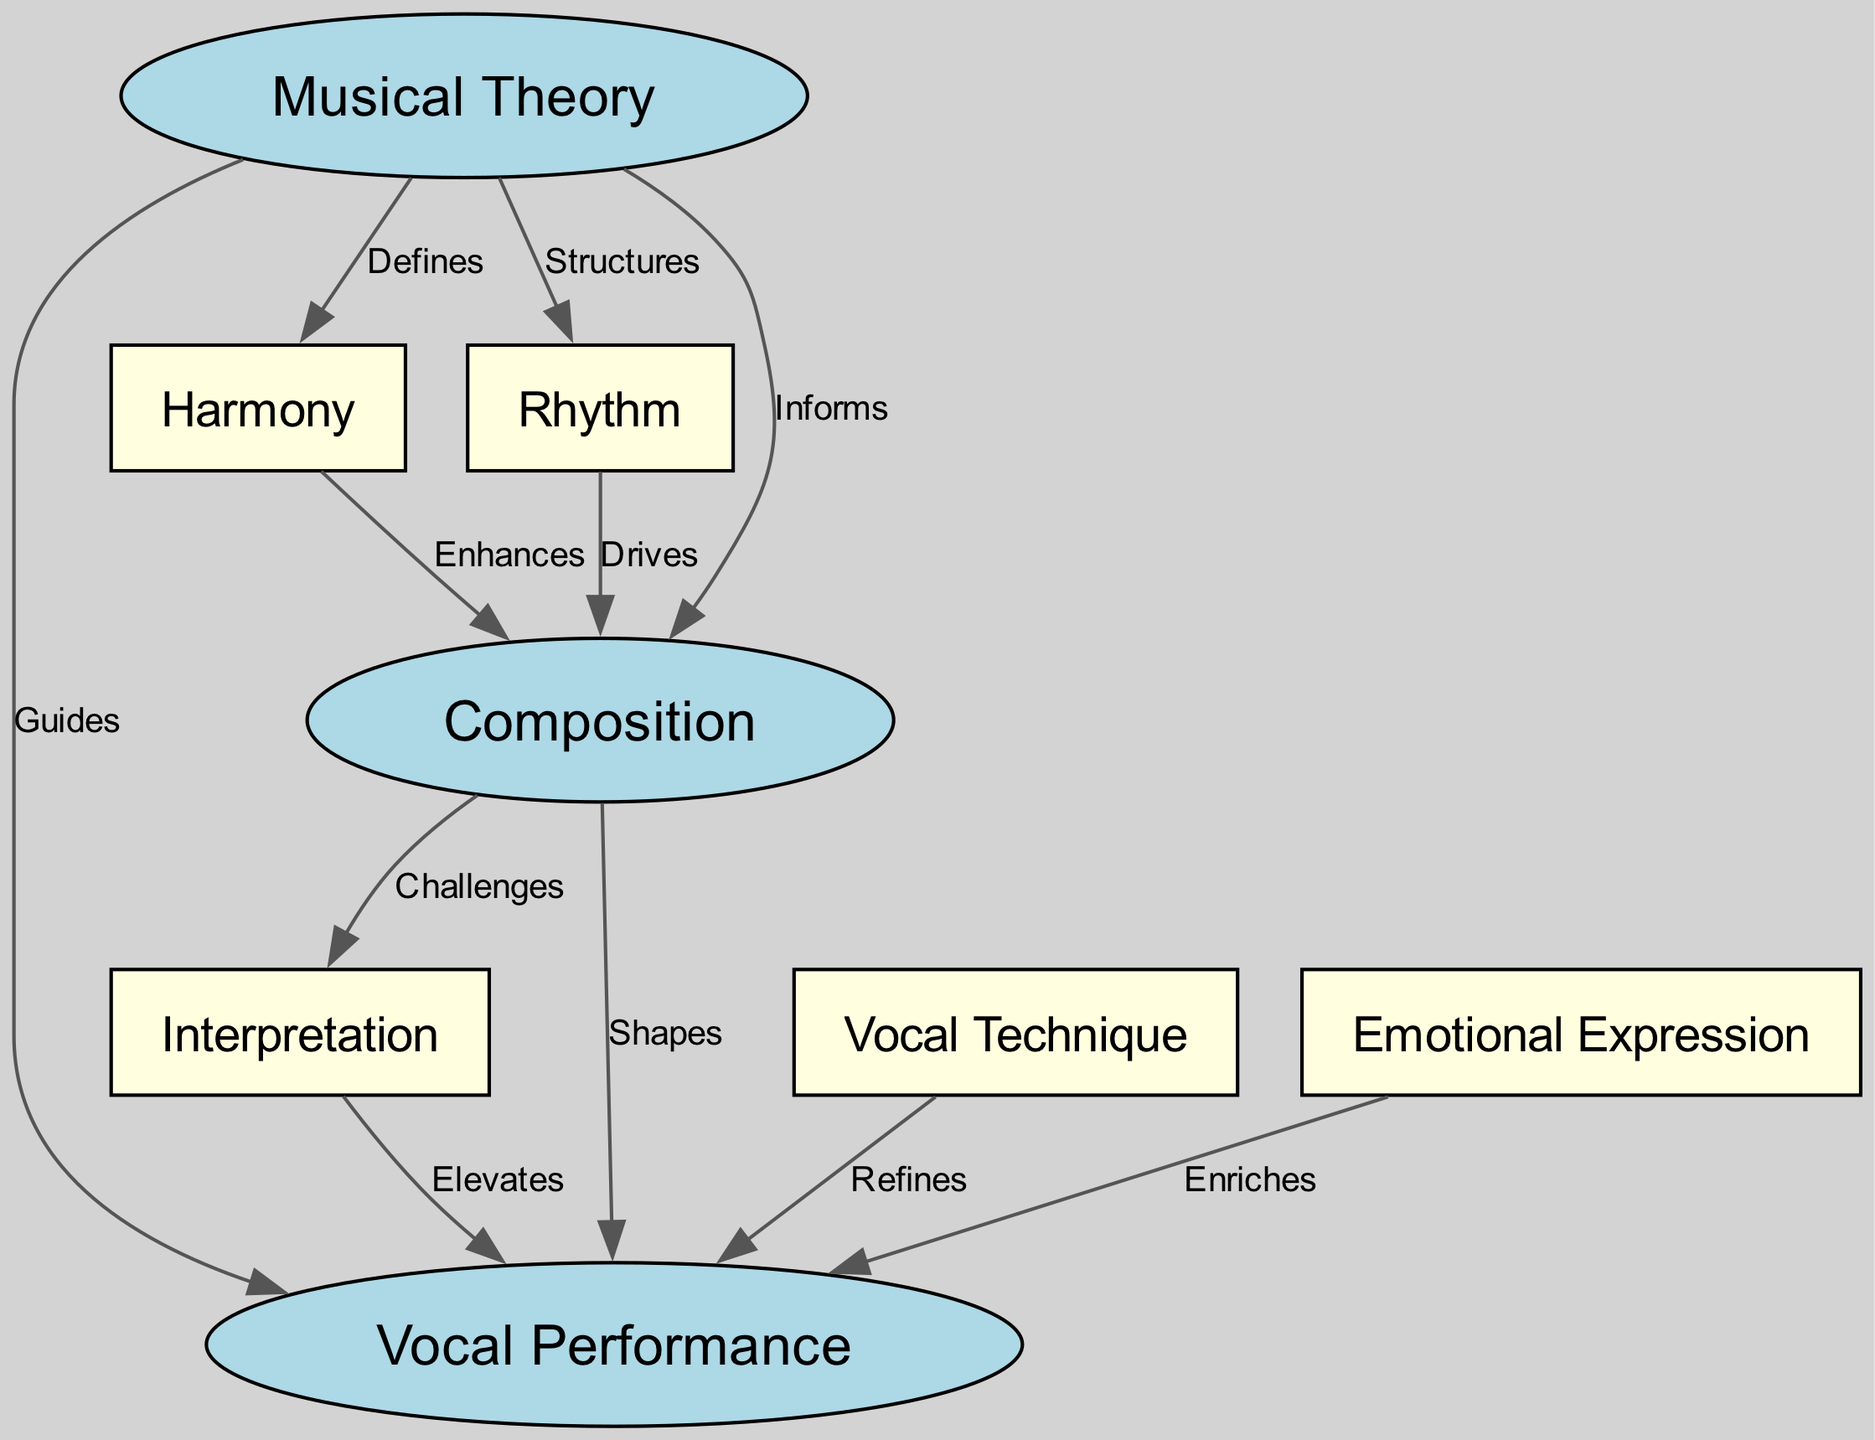What is the central node in the diagram? The central node is often defined as the most interconnected or pivotal element within the concept map. Here, "Vocal Performance" is connected to multiple nodes, indicating its importance in the relationships depicted.
Answer: Vocal Performance How many nodes are in the diagram? To determine the total number of nodes, we can simply count them as listed in the data. The nodes listed are Musical Theory, Composition, Vocal Performance, Harmony, Rhythm, Interpretation, Vocal Technique, and Emotional Expression, totaling eight nodes.
Answer: 8 What relationship does musical theory have with composition? Based on the labeled edge in the diagram, the relationship indicates that Musical Theory "Informs" Composition. This means Musical Theory provides knowledge and guidelines that influence the process of Composition.
Answer: Informs Which node enhances composition? The edge connecting "Harmony" to "Composition" indicates that Harmony "Enhances" Composition. This suggests that the principles of harmony contribute positively and creatively to the act of composing music.
Answer: Enhances How many edges lead from composition to other nodes? By visually analyzing the connections from the "Composition" node, we observe it has three edges leading to other nodes: one to Vocal Performance, one to Harmony, and one to Rhythm. This indicates that Composition influences multiple aspects of music theory and practice.
Answer: 3 What does interpretation do for vocal performance? The edge labeled "Elevates" between "Interpretation" and "Vocal Performance" shows that Interpretation enhances the quality and impact of Vocal Performance by adding depth to how a piece is sung.
Answer: Elevates Which element defines harmony? According to the diagram, Musical Theory is the node that "Defines" Harmony. This connection expresses that the principles and rules of Musical Theory establish and clarify what Harmony entails.
Answer: Defines What is the relationship between rhythm and composition? The diagram denotes that Rhythm "Drives" Composition. This suggests that rhythm plays a fundamental role in shaping how compositions are structured and articulated in musical pieces.
Answer: Drives What relationship challenges interpretation? The edge between "Composition" and "Interpretation" denotes that Composition "Challenges" Interpretation. This indicates that the act of composing music may create new interpretative possibilities or difficulties for vocalists.
Answer: Challenges 